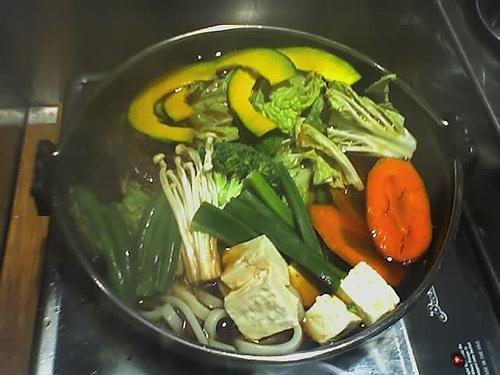How many different vegetables can be seen?
Give a very brief answer. 7. How many pieces of carrots are there?
Give a very brief answer. 3. How many pieces of tofu are there?
Give a very brief answer. 4. How many handles are on the pot?
Give a very brief answer. 2. 